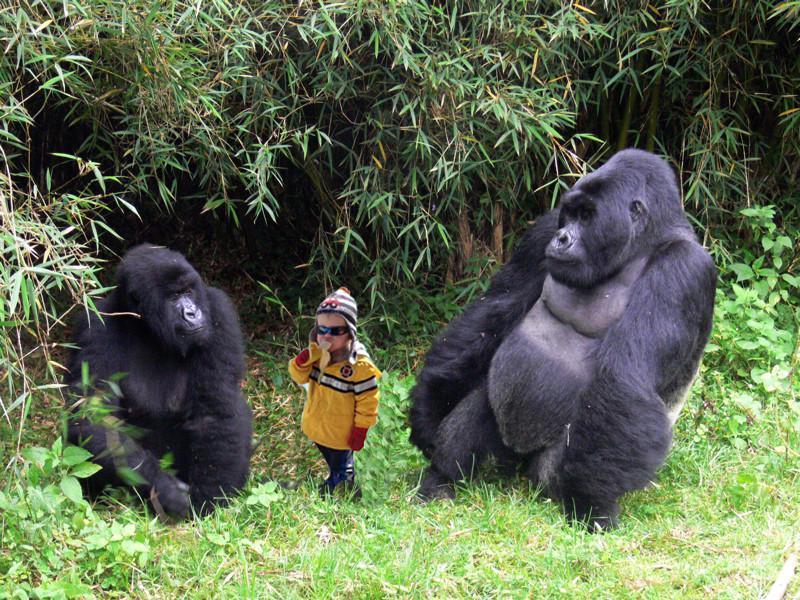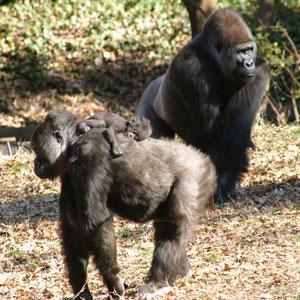The first image is the image on the left, the second image is the image on the right. Considering the images on both sides, is "At least one of the photos contains three or more apes." valid? Answer yes or no. Yes. The first image is the image on the left, the second image is the image on the right. Considering the images on both sides, is "The left image depicts only one adult ape, which has an arm around a younger ape." valid? Answer yes or no. No. 